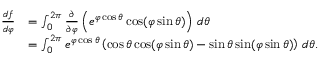<formula> <loc_0><loc_0><loc_500><loc_500>{ \begin{array} { r l } { { \frac { d f } { d \varphi } } } & { = \int _ { 0 } ^ { 2 \pi } { \frac { \partial } { \partial \varphi } } \left ( e ^ { \varphi \cos \theta } \cos ( \varphi \sin \theta ) \right ) \, d \theta } \\ & { = \int _ { 0 } ^ { 2 \pi } e ^ { \varphi \cos \theta } \left ( \cos \theta \cos ( \varphi \sin \theta ) - \sin \theta \sin ( \varphi \sin \theta ) \right ) \, d \theta . } \end{array} }</formula> 